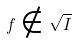<formula> <loc_0><loc_0><loc_500><loc_500>f \notin \sqrt { I }</formula> 